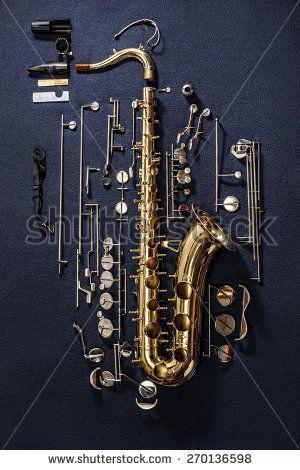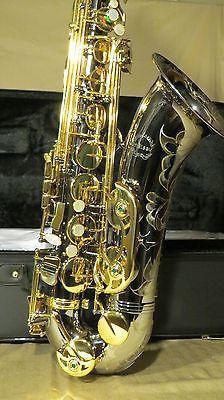The first image is the image on the left, the second image is the image on the right. Evaluate the accuracy of this statement regarding the images: "At least two intact brass-colored saxophones are displayed with the bell facing rightward.". Is it true? Answer yes or no. Yes. 